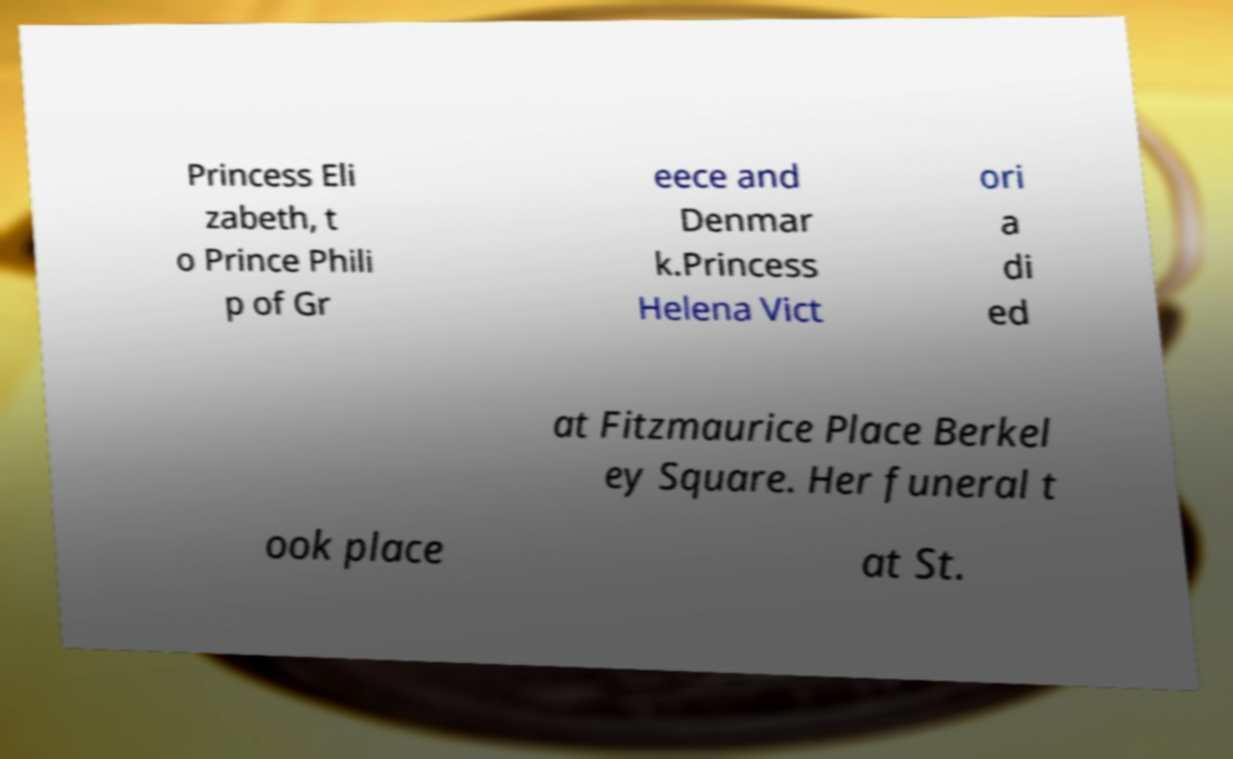Could you assist in decoding the text presented in this image and type it out clearly? Princess Eli zabeth, t o Prince Phili p of Gr eece and Denmar k.Princess Helena Vict ori a di ed at Fitzmaurice Place Berkel ey Square. Her funeral t ook place at St. 